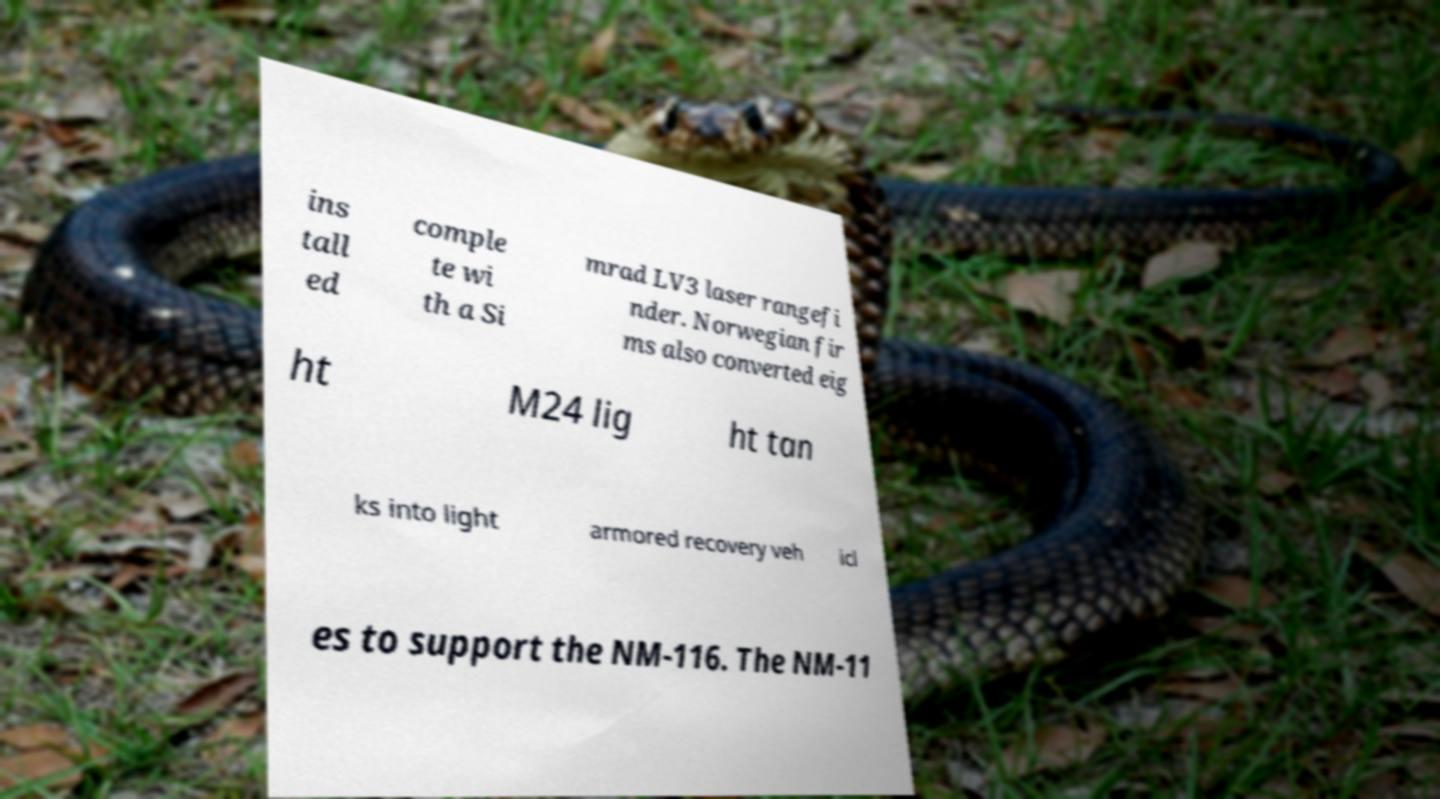Can you read and provide the text displayed in the image?This photo seems to have some interesting text. Can you extract and type it out for me? ins tall ed comple te wi th a Si mrad LV3 laser rangefi nder. Norwegian fir ms also converted eig ht M24 lig ht tan ks into light armored recovery veh icl es to support the NM-116. The NM-11 